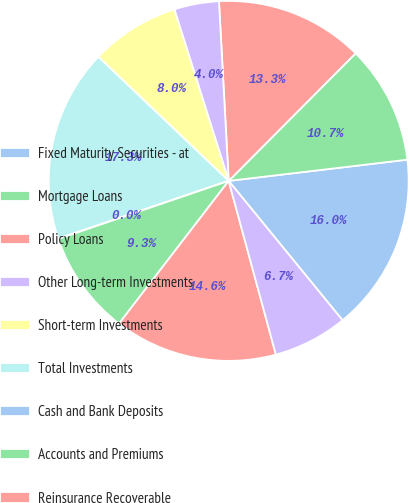<chart> <loc_0><loc_0><loc_500><loc_500><pie_chart><fcel>Fixed Maturity Securities - at<fcel>Mortgage Loans<fcel>Policy Loans<fcel>Other Long-term Investments<fcel>Short-term Investments<fcel>Total Investments<fcel>Cash and Bank Deposits<fcel>Accounts and Premiums<fcel>Reinsurance Recoverable<fcel>Accrued Investment Income<nl><fcel>15.98%<fcel>10.66%<fcel>13.32%<fcel>4.02%<fcel>8.01%<fcel>17.31%<fcel>0.03%<fcel>9.34%<fcel>14.65%<fcel>6.68%<nl></chart> 